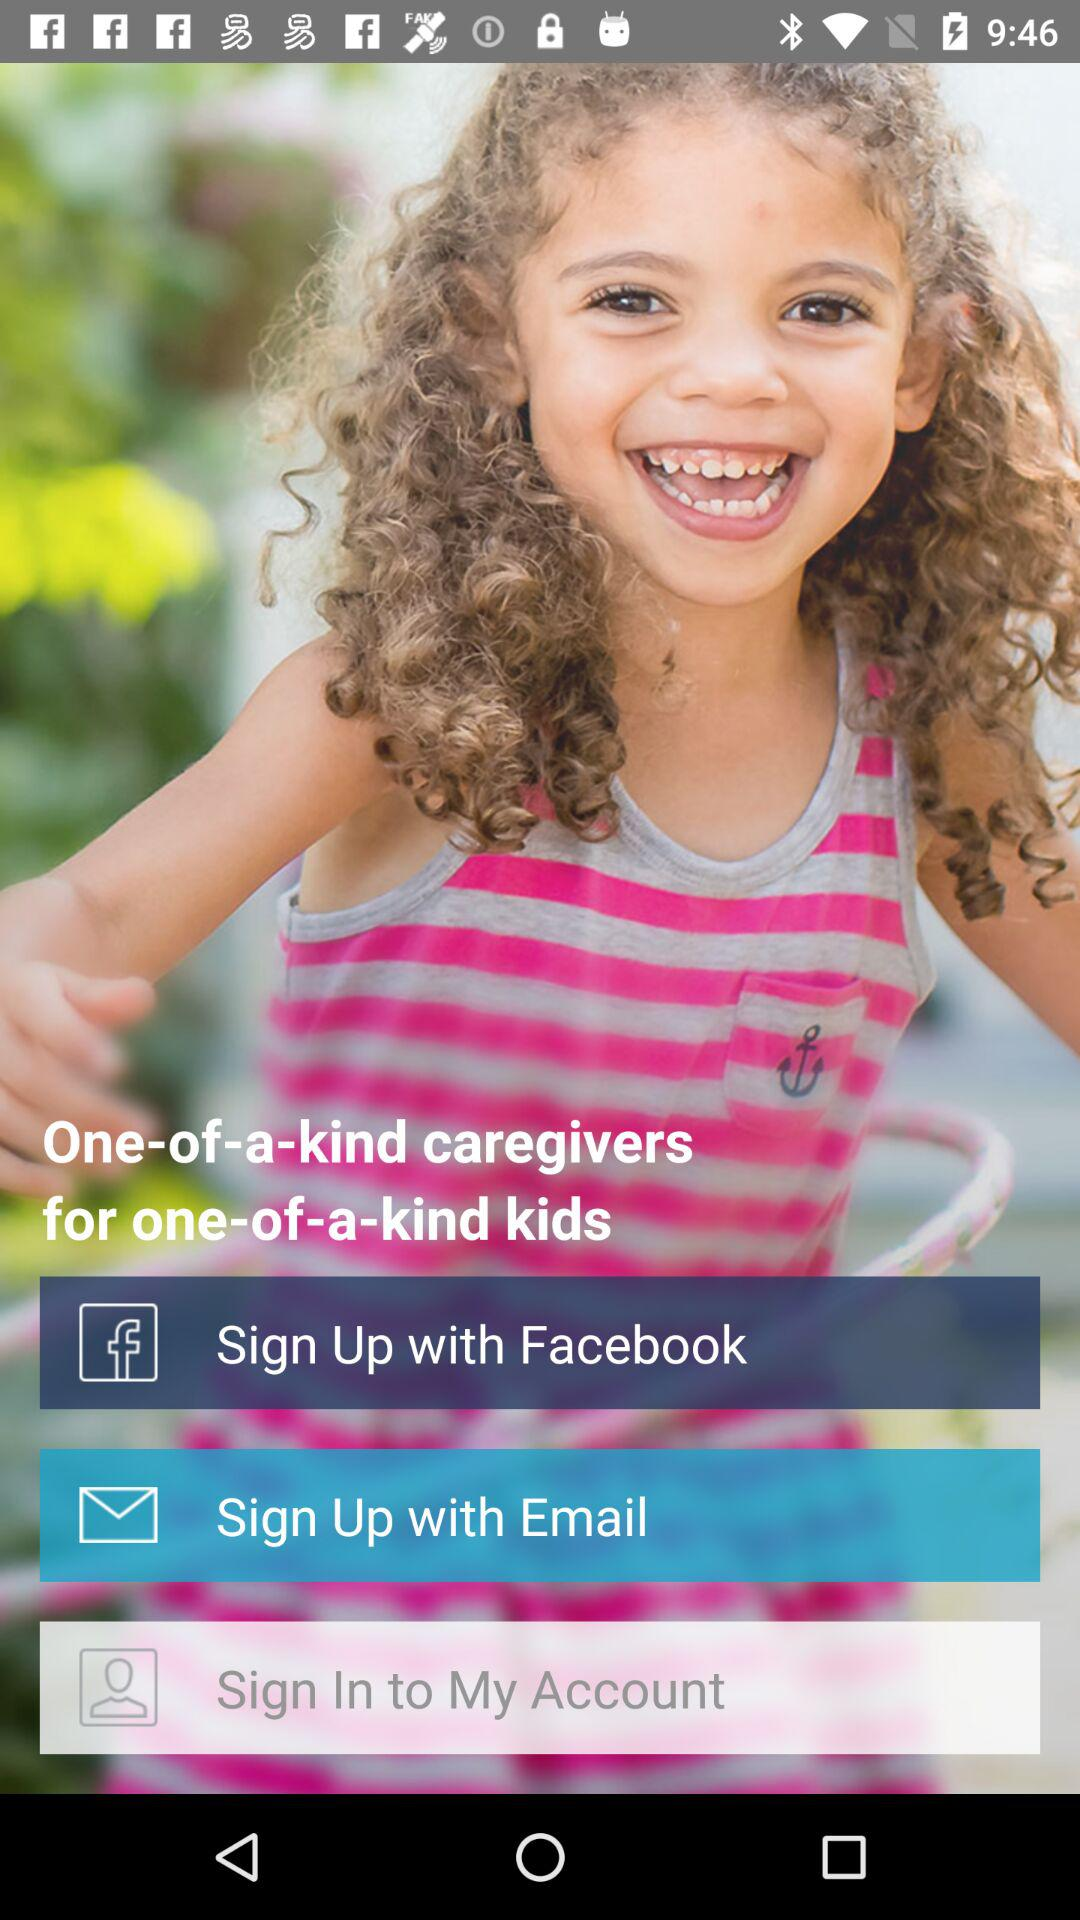What are the different options available for signing up? The different options available for signing up are "Facebook" and "Email". 